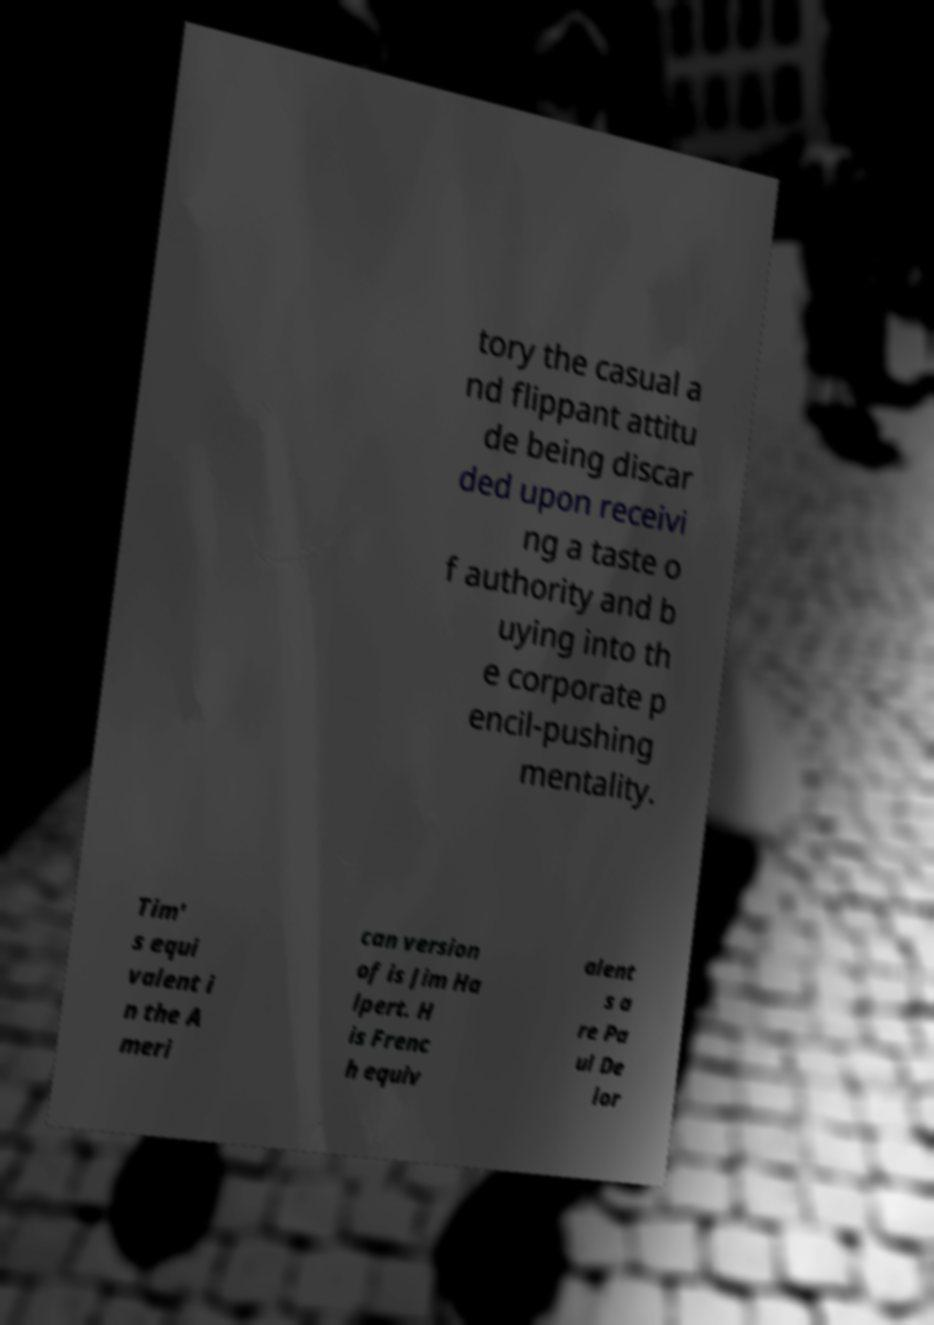Please identify and transcribe the text found in this image. tory the casual a nd flippant attitu de being discar ded upon receivi ng a taste o f authority and b uying into th e corporate p encil-pushing mentality. Tim' s equi valent i n the A meri can version of is Jim Ha lpert. H is Frenc h equiv alent s a re Pa ul De lor 